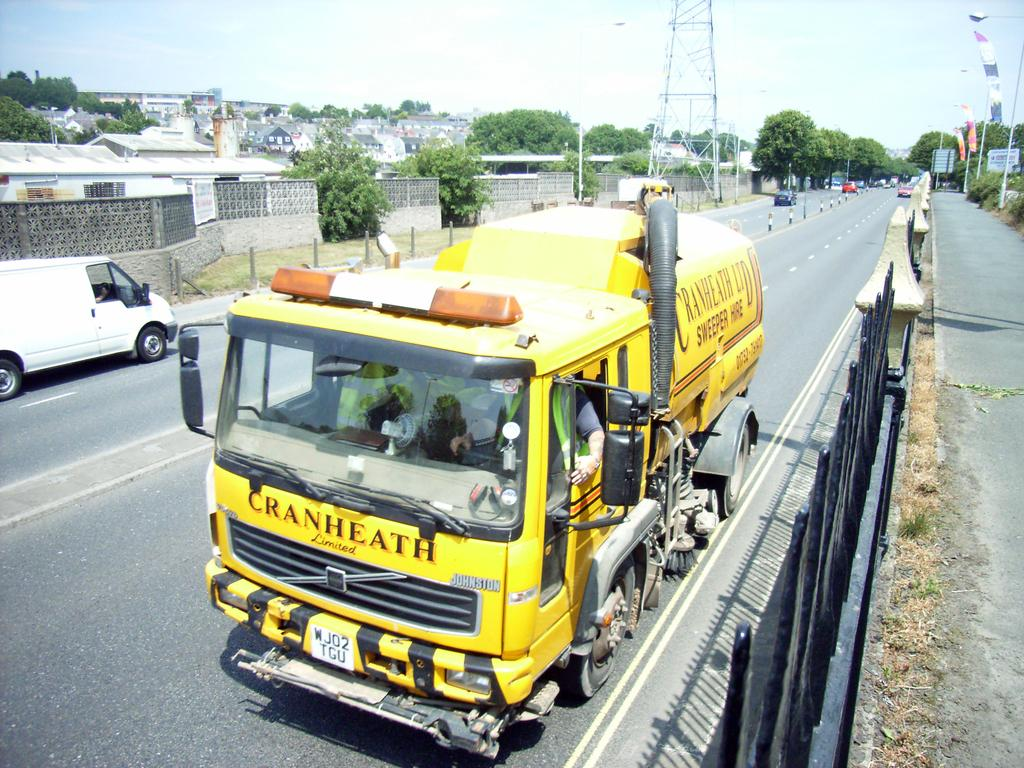What can be seen on the road in the image? There are vehicles on the road in the image. What is located on the left side of the image? There are buildings, trees, a tower, and street lights on the left side of the image. Can you see your aunt wearing a collar in the image? There is no person, let alone an aunt, present in the image. Is the sea visible in the image? No, the sea is not visible in the image; it features vehicles on the road and structures on the left side. 